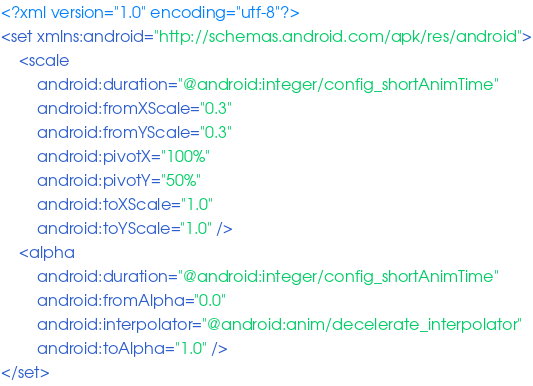<code> <loc_0><loc_0><loc_500><loc_500><_XML_><?xml version="1.0" encoding="utf-8"?>
<set xmlns:android="http://schemas.android.com/apk/res/android">
    <scale
        android:duration="@android:integer/config_shortAnimTime"
        android:fromXScale="0.3"
        android:fromYScale="0.3"
        android:pivotX="100%"
        android:pivotY="50%"
        android:toXScale="1.0"
        android:toYScale="1.0" />
    <alpha
        android:duration="@android:integer/config_shortAnimTime"
        android:fromAlpha="0.0"
        android:interpolator="@android:anim/decelerate_interpolator"
        android:toAlpha="1.0" />
</set></code> 